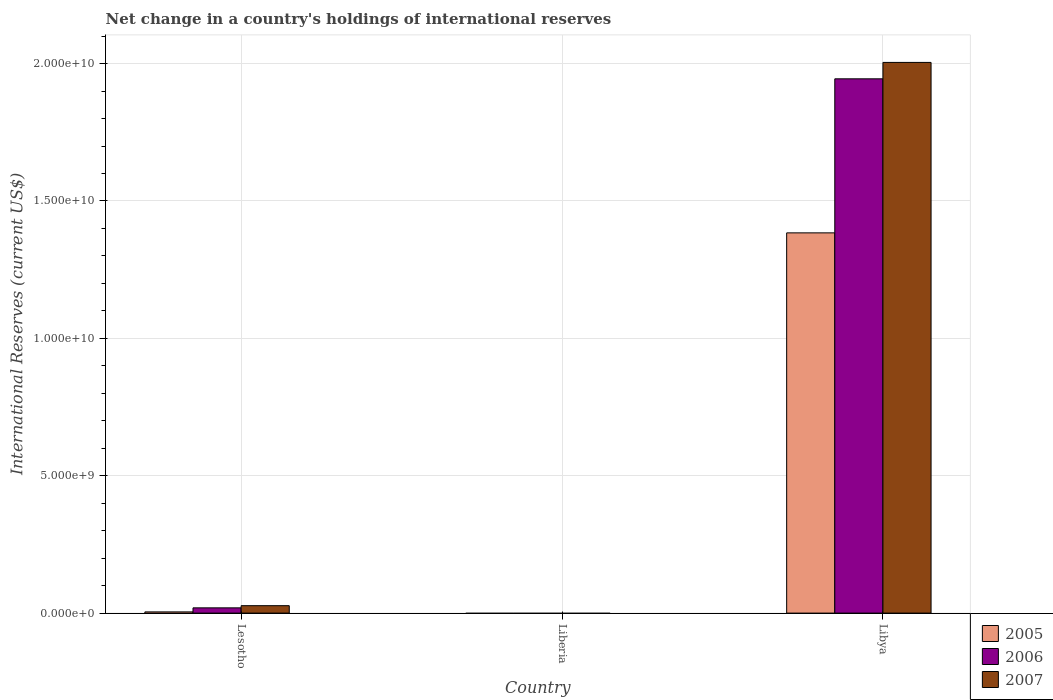How many different coloured bars are there?
Your response must be concise. 3. How many bars are there on the 1st tick from the left?
Give a very brief answer. 3. How many bars are there on the 1st tick from the right?
Give a very brief answer. 3. What is the label of the 2nd group of bars from the left?
Make the answer very short. Liberia. In how many cases, is the number of bars for a given country not equal to the number of legend labels?
Ensure brevity in your answer.  1. What is the international reserves in 2007 in Libya?
Your response must be concise. 2.00e+1. Across all countries, what is the maximum international reserves in 2007?
Keep it short and to the point. 2.00e+1. In which country was the international reserves in 2007 maximum?
Keep it short and to the point. Libya. What is the total international reserves in 2006 in the graph?
Offer a terse response. 1.96e+1. What is the difference between the international reserves in 2007 in Lesotho and that in Libya?
Your answer should be compact. -1.98e+1. What is the difference between the international reserves in 2006 in Liberia and the international reserves in 2007 in Lesotho?
Offer a very short reply. -2.70e+08. What is the average international reserves in 2005 per country?
Keep it short and to the point. 4.63e+09. What is the difference between the international reserves of/in 2005 and international reserves of/in 2006 in Libya?
Keep it short and to the point. -5.61e+09. What is the ratio of the international reserves in 2005 in Lesotho to that in Libya?
Your answer should be compact. 0. Is the international reserves in 2005 in Lesotho less than that in Libya?
Your response must be concise. Yes. Is the difference between the international reserves in 2005 in Lesotho and Libya greater than the difference between the international reserves in 2006 in Lesotho and Libya?
Offer a terse response. Yes. What is the difference between the highest and the lowest international reserves in 2005?
Ensure brevity in your answer.  1.38e+1. In how many countries, is the international reserves in 2006 greater than the average international reserves in 2006 taken over all countries?
Offer a very short reply. 1. Is the sum of the international reserves in 2005 in Lesotho and Libya greater than the maximum international reserves in 2006 across all countries?
Ensure brevity in your answer.  No. Is it the case that in every country, the sum of the international reserves in 2005 and international reserves in 2007 is greater than the international reserves in 2006?
Give a very brief answer. No. Are the values on the major ticks of Y-axis written in scientific E-notation?
Offer a very short reply. Yes. Does the graph contain any zero values?
Ensure brevity in your answer.  Yes. Does the graph contain grids?
Keep it short and to the point. Yes. How many legend labels are there?
Make the answer very short. 3. How are the legend labels stacked?
Provide a short and direct response. Vertical. What is the title of the graph?
Make the answer very short. Net change in a country's holdings of international reserves. What is the label or title of the X-axis?
Provide a short and direct response. Country. What is the label or title of the Y-axis?
Your answer should be very brief. International Reserves (current US$). What is the International Reserves (current US$) in 2005 in Lesotho?
Your response must be concise. 4.37e+07. What is the International Reserves (current US$) in 2006 in Lesotho?
Offer a very short reply. 1.91e+08. What is the International Reserves (current US$) of 2007 in Lesotho?
Your answer should be compact. 2.70e+08. What is the International Reserves (current US$) of 2006 in Liberia?
Make the answer very short. 0. What is the International Reserves (current US$) of 2005 in Libya?
Offer a terse response. 1.38e+1. What is the International Reserves (current US$) in 2006 in Libya?
Provide a short and direct response. 1.94e+1. What is the International Reserves (current US$) of 2007 in Libya?
Make the answer very short. 2.00e+1. Across all countries, what is the maximum International Reserves (current US$) in 2005?
Offer a terse response. 1.38e+1. Across all countries, what is the maximum International Reserves (current US$) of 2006?
Your answer should be very brief. 1.94e+1. Across all countries, what is the maximum International Reserves (current US$) of 2007?
Give a very brief answer. 2.00e+1. Across all countries, what is the minimum International Reserves (current US$) in 2007?
Make the answer very short. 0. What is the total International Reserves (current US$) of 2005 in the graph?
Provide a succinct answer. 1.39e+1. What is the total International Reserves (current US$) of 2006 in the graph?
Provide a short and direct response. 1.96e+1. What is the total International Reserves (current US$) of 2007 in the graph?
Keep it short and to the point. 2.03e+1. What is the difference between the International Reserves (current US$) in 2005 in Lesotho and that in Libya?
Make the answer very short. -1.38e+1. What is the difference between the International Reserves (current US$) in 2006 in Lesotho and that in Libya?
Ensure brevity in your answer.  -1.93e+1. What is the difference between the International Reserves (current US$) of 2007 in Lesotho and that in Libya?
Your answer should be compact. -1.98e+1. What is the difference between the International Reserves (current US$) of 2005 in Lesotho and the International Reserves (current US$) of 2006 in Libya?
Keep it short and to the point. -1.94e+1. What is the difference between the International Reserves (current US$) in 2005 in Lesotho and the International Reserves (current US$) in 2007 in Libya?
Provide a succinct answer. -2.00e+1. What is the difference between the International Reserves (current US$) of 2006 in Lesotho and the International Reserves (current US$) of 2007 in Libya?
Your answer should be compact. -1.99e+1. What is the average International Reserves (current US$) of 2005 per country?
Provide a short and direct response. 4.63e+09. What is the average International Reserves (current US$) of 2006 per country?
Offer a very short reply. 6.55e+09. What is the average International Reserves (current US$) in 2007 per country?
Offer a very short reply. 6.77e+09. What is the difference between the International Reserves (current US$) of 2005 and International Reserves (current US$) of 2006 in Lesotho?
Keep it short and to the point. -1.47e+08. What is the difference between the International Reserves (current US$) in 2005 and International Reserves (current US$) in 2007 in Lesotho?
Offer a terse response. -2.26e+08. What is the difference between the International Reserves (current US$) of 2006 and International Reserves (current US$) of 2007 in Lesotho?
Ensure brevity in your answer.  -7.91e+07. What is the difference between the International Reserves (current US$) of 2005 and International Reserves (current US$) of 2006 in Libya?
Provide a short and direct response. -5.61e+09. What is the difference between the International Reserves (current US$) of 2005 and International Reserves (current US$) of 2007 in Libya?
Offer a terse response. -6.20e+09. What is the difference between the International Reserves (current US$) in 2006 and International Reserves (current US$) in 2007 in Libya?
Make the answer very short. -5.98e+08. What is the ratio of the International Reserves (current US$) in 2005 in Lesotho to that in Libya?
Make the answer very short. 0. What is the ratio of the International Reserves (current US$) of 2006 in Lesotho to that in Libya?
Offer a very short reply. 0.01. What is the ratio of the International Reserves (current US$) of 2007 in Lesotho to that in Libya?
Ensure brevity in your answer.  0.01. What is the difference between the highest and the lowest International Reserves (current US$) of 2005?
Ensure brevity in your answer.  1.38e+1. What is the difference between the highest and the lowest International Reserves (current US$) in 2006?
Provide a short and direct response. 1.94e+1. What is the difference between the highest and the lowest International Reserves (current US$) of 2007?
Your answer should be compact. 2.00e+1. 